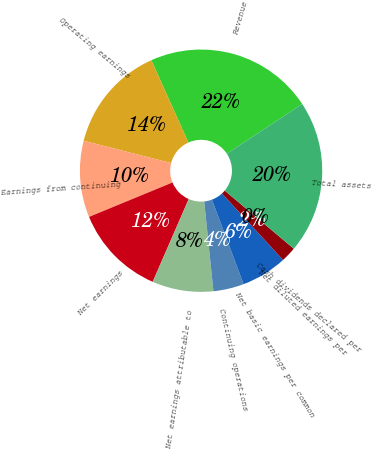Convert chart. <chart><loc_0><loc_0><loc_500><loc_500><pie_chart><fcel>Revenue<fcel>Operating earnings<fcel>Earnings from continuing<fcel>Net earnings<fcel>Net earnings attributable to<fcel>Continuing operations<fcel>Net basic earnings per common<fcel>Net diluted earnings per<fcel>Cash dividends declared per<fcel>Total assets<nl><fcel>22.45%<fcel>14.29%<fcel>10.2%<fcel>12.24%<fcel>8.16%<fcel>4.08%<fcel>6.12%<fcel>2.04%<fcel>0.0%<fcel>20.41%<nl></chart> 